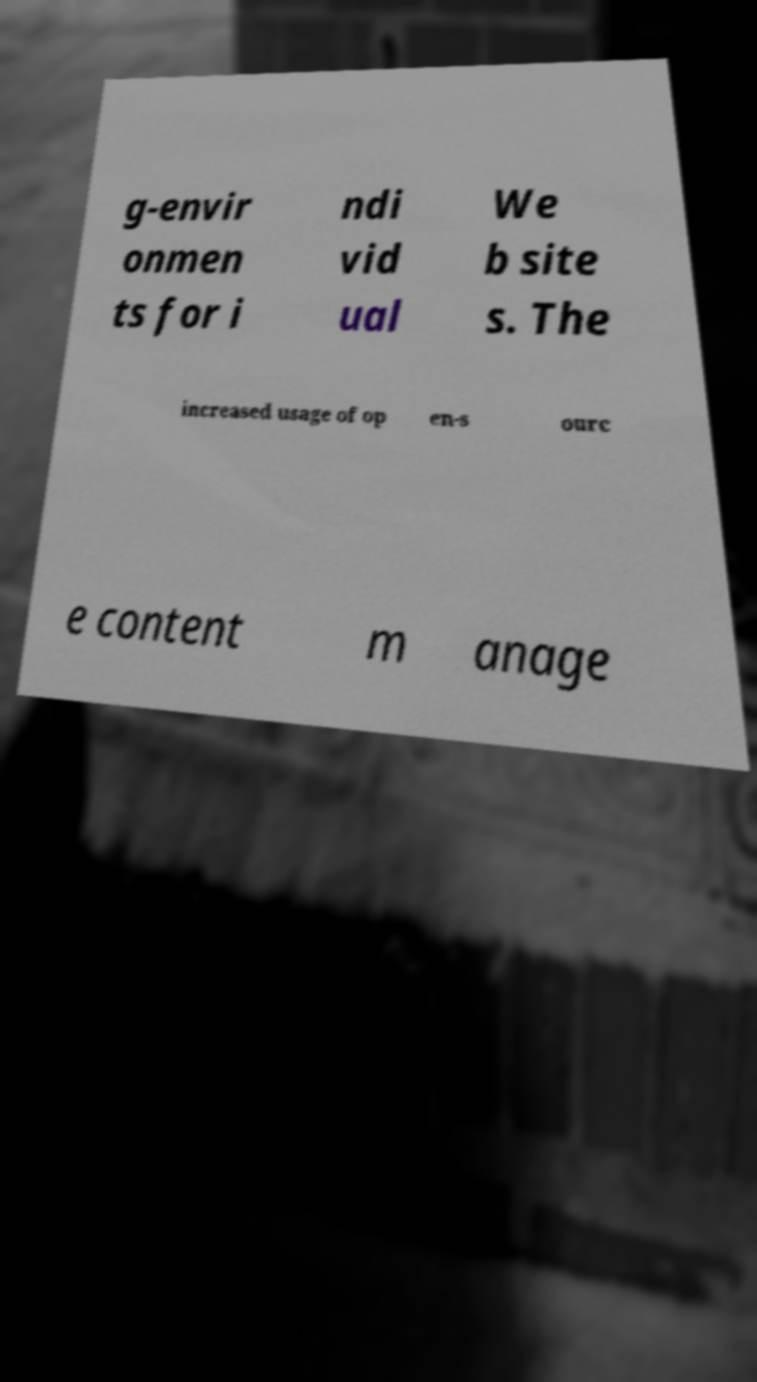For documentation purposes, I need the text within this image transcribed. Could you provide that? g-envir onmen ts for i ndi vid ual We b site s. The increased usage of op en-s ourc e content m anage 